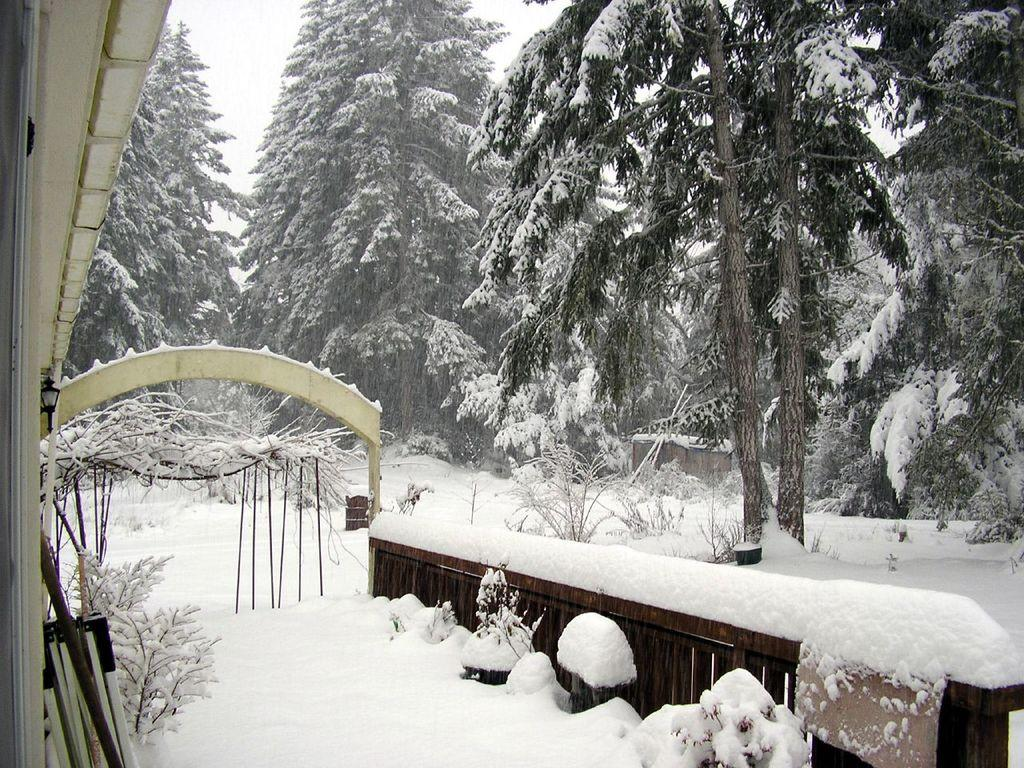What type of living organisms can be seen in the image? Plants can be seen in the image. What material is the wooden object made of? The wooden object in the image is made of wood. What is the weather like in the image? The presence of snow suggests that it is cold and possibly winter. What architectural feature is present in the image? There is an arch in the image. What is visible in the background of the image? Trees and the sky are visible in the background of the image. Can you tell me how many forks are placed on the windowsill in the image? There are no forks or windowsills present in the image. What type of creature is shown interacting with the trees in the image? There is no creature shown interacting with the trees in the image; only the plants, wooden object, snow, roof top, arch, trees, and sky are present. 